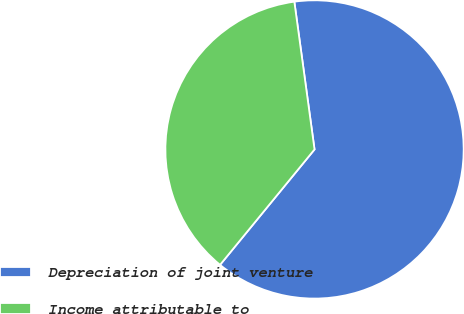Convert chart to OTSL. <chart><loc_0><loc_0><loc_500><loc_500><pie_chart><fcel>Depreciation of joint venture<fcel>Income attributable to<nl><fcel>63.08%<fcel>36.92%<nl></chart> 